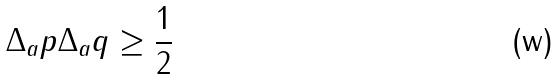<formula> <loc_0><loc_0><loc_500><loc_500>\Delta _ { a } p \Delta _ { a } q \geq \frac { 1 } { 2 }</formula> 